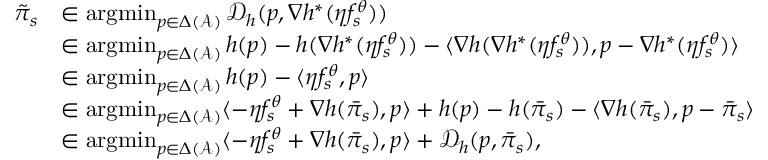<formula> <loc_0><loc_0><loc_500><loc_500>\begin{array} { r l } { \tilde { \pi } _ { s } } & { \in \arg \min _ { p \in \Delta ( \mathcal { A } ) } \mathcal { D } _ { h } ( p , \nabla h ^ { * } ( \eta f _ { s } ^ { \theta } ) ) } \\ & { \in \arg \min _ { p \in \Delta ( \mathcal { A } ) } h ( p ) - h ( \nabla h ^ { * } ( \eta f _ { s } ^ { \theta } ) ) - \langle \nabla h ( \nabla h ^ { * } ( \eta f _ { s } ^ { \theta } ) ) , p - \nabla h ^ { * } ( \eta f _ { s } ^ { \theta } ) \rangle } \\ & { \in \arg \min _ { p \in \Delta ( \mathcal { A } ) } h ( p ) - \langle \eta f _ { s } ^ { \theta } , p \rangle } \\ & { \in \arg \min _ { p \in \Delta ( \mathcal { A } ) } \langle - \eta f _ { s } ^ { \theta } + \nabla h ( \bar { \pi } _ { s } ) , p \rangle + h ( p ) - h ( \bar { \pi } _ { s } ) - \langle \nabla h ( \bar { \pi } _ { s } ) , p - \bar { \pi } _ { s } \rangle } \\ & { \in \arg \min _ { p \in \Delta ( \mathcal { A } ) } \langle - \eta f _ { s } ^ { \theta } + \nabla h ( \bar { \pi } _ { s } ) , p \rangle + \mathcal { D } _ { h } ( p , \bar { \pi } _ { s } ) , } \end{array}</formula> 